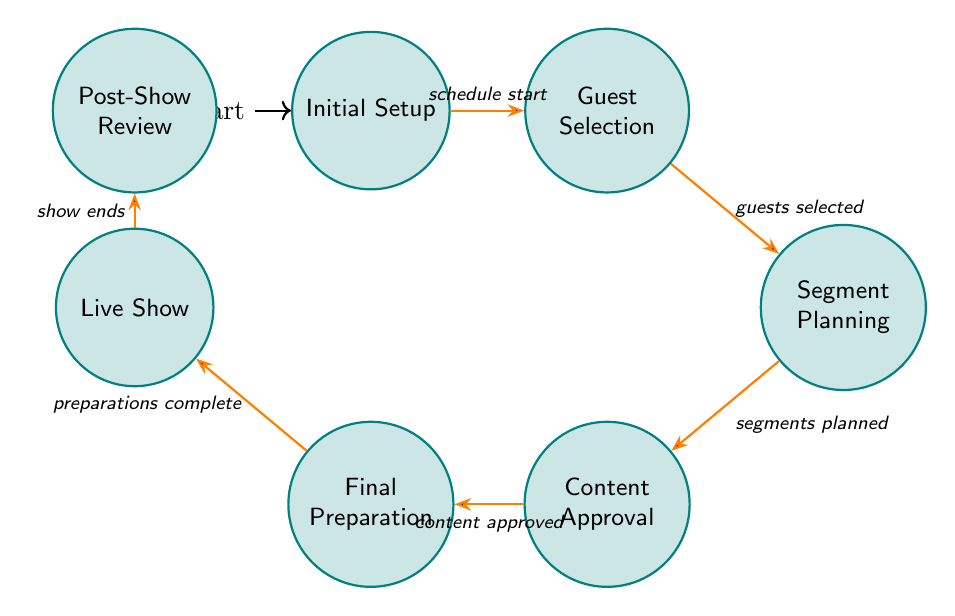What is the initial state of the diagram? The initial state is represented as the starting point, which is the node labeled "Initial Setup". This is visually marked in the diagram as the node that has an incoming arrow and is the first one in the flow.
Answer: Initial Setup How many states are present in the diagram? To find the total number of states, we can count all unique nodes depicted in the diagram. There are seven states: Initial Setup, Guest Selection, Segment Planning, Content Approval, Final Preparation, Live Show, and Post-Show Review.
Answer: 7 What is the transition that follows the "Guest Selection" state? The transition from the "Guest Selection" state moves to the "Segment Planning" state upon the trigger "guests selected". We can visually check the arrow leading from one node to another.
Answer: Segment Planning Which state follows "Final Preparation"? The state that follows "Final Preparation" is "Live Show". This is determined by identifying the arrow that directly connects these two nodes in the flow of the diagram.
Answer: Live Show What triggers the transition from "Content Approval" to "Final Preparation"? The transition from "Content Approval" to "Final Preparation" is triggered when the content is approved. This is indicated along the connecting arrow in the diagram that labels the condition for that transition.
Answer: content approved What is the final state after the "Live Show"? After the "Live Show", the flow diagram indicates a transition to the "Post-Show Review" state. The arrow leads from the "Live Show" node to the "Post-Show Review" node, showing the sequence of operations.
Answer: Post-Show Review How many transitions are present in the diagram? The number of transitions can be counted by looking at the arrows connecting the various states. There are six distinct transitions that illustrate the flow between the states in the diagram.
Answer: 6 Which state is reached after the "Segment Planning" state? Once the "Segment Planning" state is completed, the next state reached is "Content Approval". This is deduced from the flow direction indicated by the arrow connecting these two nodes.
Answer: Content Approval 